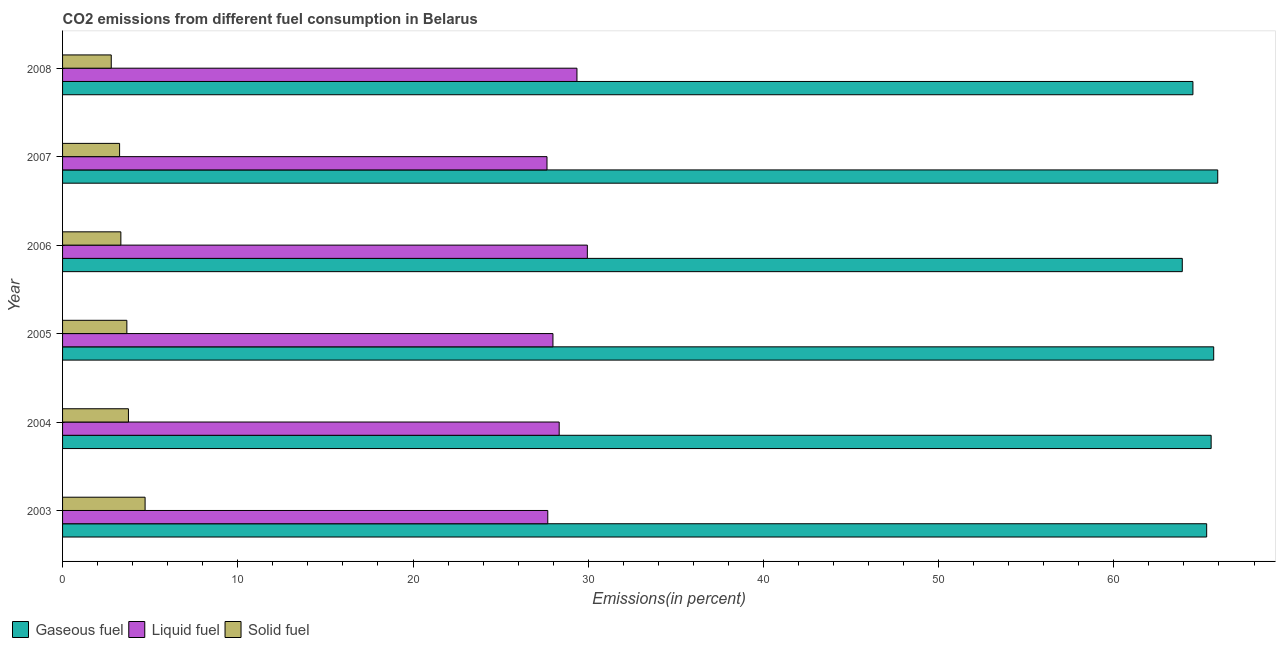How many different coloured bars are there?
Your answer should be very brief. 3. How many groups of bars are there?
Keep it short and to the point. 6. Are the number of bars per tick equal to the number of legend labels?
Offer a very short reply. Yes. What is the percentage of liquid fuel emission in 2006?
Offer a terse response. 29.95. Across all years, what is the maximum percentage of gaseous fuel emission?
Give a very brief answer. 65.93. Across all years, what is the minimum percentage of liquid fuel emission?
Your answer should be compact. 27.65. What is the total percentage of solid fuel emission in the graph?
Make the answer very short. 21.5. What is the difference between the percentage of gaseous fuel emission in 2008 and the percentage of solid fuel emission in 2003?
Make the answer very short. 59.8. What is the average percentage of gaseous fuel emission per year?
Offer a very short reply. 65.15. In the year 2003, what is the difference between the percentage of gaseous fuel emission and percentage of solid fuel emission?
Offer a terse response. 60.59. In how many years, is the percentage of solid fuel emission greater than 58 %?
Provide a short and direct response. 0. What is the ratio of the percentage of solid fuel emission in 2005 to that in 2007?
Provide a short and direct response. 1.13. Is the percentage of liquid fuel emission in 2003 less than that in 2004?
Keep it short and to the point. Yes. Is the difference between the percentage of liquid fuel emission in 2006 and 2008 greater than the difference between the percentage of solid fuel emission in 2006 and 2008?
Provide a short and direct response. Yes. What is the difference between the highest and the second highest percentage of gaseous fuel emission?
Ensure brevity in your answer.  0.23. What is the difference between the highest and the lowest percentage of gaseous fuel emission?
Your answer should be compact. 2.02. What does the 3rd bar from the top in 2008 represents?
Provide a short and direct response. Gaseous fuel. What does the 1st bar from the bottom in 2004 represents?
Offer a terse response. Gaseous fuel. How many bars are there?
Make the answer very short. 18. Are all the bars in the graph horizontal?
Provide a succinct answer. Yes. What is the difference between two consecutive major ticks on the X-axis?
Make the answer very short. 10. How are the legend labels stacked?
Your answer should be very brief. Horizontal. What is the title of the graph?
Your response must be concise. CO2 emissions from different fuel consumption in Belarus. What is the label or title of the X-axis?
Offer a very short reply. Emissions(in percent). What is the label or title of the Y-axis?
Make the answer very short. Year. What is the Emissions(in percent) of Gaseous fuel in 2003?
Offer a very short reply. 65.3. What is the Emissions(in percent) in Liquid fuel in 2003?
Offer a very short reply. 27.69. What is the Emissions(in percent) of Solid fuel in 2003?
Your answer should be compact. 4.71. What is the Emissions(in percent) of Gaseous fuel in 2004?
Provide a short and direct response. 65.55. What is the Emissions(in percent) in Liquid fuel in 2004?
Keep it short and to the point. 28.34. What is the Emissions(in percent) in Solid fuel in 2004?
Keep it short and to the point. 3.76. What is the Emissions(in percent) of Gaseous fuel in 2005?
Offer a very short reply. 65.7. What is the Emissions(in percent) in Liquid fuel in 2005?
Ensure brevity in your answer.  27.99. What is the Emissions(in percent) of Solid fuel in 2005?
Ensure brevity in your answer.  3.67. What is the Emissions(in percent) in Gaseous fuel in 2006?
Ensure brevity in your answer.  63.9. What is the Emissions(in percent) of Liquid fuel in 2006?
Your answer should be compact. 29.95. What is the Emissions(in percent) in Solid fuel in 2006?
Provide a short and direct response. 3.33. What is the Emissions(in percent) in Gaseous fuel in 2007?
Ensure brevity in your answer.  65.93. What is the Emissions(in percent) in Liquid fuel in 2007?
Your response must be concise. 27.65. What is the Emissions(in percent) in Solid fuel in 2007?
Provide a short and direct response. 3.25. What is the Emissions(in percent) of Gaseous fuel in 2008?
Provide a short and direct response. 64.51. What is the Emissions(in percent) in Liquid fuel in 2008?
Make the answer very short. 29.36. What is the Emissions(in percent) in Solid fuel in 2008?
Keep it short and to the point. 2.78. Across all years, what is the maximum Emissions(in percent) in Gaseous fuel?
Make the answer very short. 65.93. Across all years, what is the maximum Emissions(in percent) of Liquid fuel?
Offer a terse response. 29.95. Across all years, what is the maximum Emissions(in percent) in Solid fuel?
Give a very brief answer. 4.71. Across all years, what is the minimum Emissions(in percent) of Gaseous fuel?
Your answer should be compact. 63.9. Across all years, what is the minimum Emissions(in percent) in Liquid fuel?
Provide a succinct answer. 27.65. Across all years, what is the minimum Emissions(in percent) in Solid fuel?
Offer a very short reply. 2.78. What is the total Emissions(in percent) in Gaseous fuel in the graph?
Offer a very short reply. 390.89. What is the total Emissions(in percent) of Liquid fuel in the graph?
Offer a very short reply. 170.98. What is the total Emissions(in percent) in Solid fuel in the graph?
Offer a very short reply. 21.5. What is the difference between the Emissions(in percent) of Gaseous fuel in 2003 and that in 2004?
Your answer should be compact. -0.26. What is the difference between the Emissions(in percent) of Liquid fuel in 2003 and that in 2004?
Provide a succinct answer. -0.65. What is the difference between the Emissions(in percent) in Solid fuel in 2003 and that in 2004?
Your answer should be compact. 0.95. What is the difference between the Emissions(in percent) in Gaseous fuel in 2003 and that in 2005?
Give a very brief answer. -0.4. What is the difference between the Emissions(in percent) in Liquid fuel in 2003 and that in 2005?
Provide a succinct answer. -0.29. What is the difference between the Emissions(in percent) in Solid fuel in 2003 and that in 2005?
Make the answer very short. 1.04. What is the difference between the Emissions(in percent) in Gaseous fuel in 2003 and that in 2006?
Your answer should be very brief. 1.39. What is the difference between the Emissions(in percent) of Liquid fuel in 2003 and that in 2006?
Keep it short and to the point. -2.26. What is the difference between the Emissions(in percent) in Solid fuel in 2003 and that in 2006?
Your response must be concise. 1.38. What is the difference between the Emissions(in percent) in Gaseous fuel in 2003 and that in 2007?
Keep it short and to the point. -0.63. What is the difference between the Emissions(in percent) of Liquid fuel in 2003 and that in 2007?
Provide a succinct answer. 0.05. What is the difference between the Emissions(in percent) of Solid fuel in 2003 and that in 2007?
Provide a short and direct response. 1.46. What is the difference between the Emissions(in percent) of Gaseous fuel in 2003 and that in 2008?
Your response must be concise. 0.78. What is the difference between the Emissions(in percent) in Liquid fuel in 2003 and that in 2008?
Offer a terse response. -1.67. What is the difference between the Emissions(in percent) of Solid fuel in 2003 and that in 2008?
Your response must be concise. 1.93. What is the difference between the Emissions(in percent) in Gaseous fuel in 2004 and that in 2005?
Your response must be concise. -0.15. What is the difference between the Emissions(in percent) in Liquid fuel in 2004 and that in 2005?
Provide a short and direct response. 0.36. What is the difference between the Emissions(in percent) in Solid fuel in 2004 and that in 2005?
Offer a terse response. 0.09. What is the difference between the Emissions(in percent) in Gaseous fuel in 2004 and that in 2006?
Provide a short and direct response. 1.65. What is the difference between the Emissions(in percent) of Liquid fuel in 2004 and that in 2006?
Provide a short and direct response. -1.61. What is the difference between the Emissions(in percent) of Solid fuel in 2004 and that in 2006?
Your response must be concise. 0.43. What is the difference between the Emissions(in percent) of Gaseous fuel in 2004 and that in 2007?
Your response must be concise. -0.38. What is the difference between the Emissions(in percent) of Liquid fuel in 2004 and that in 2007?
Ensure brevity in your answer.  0.7. What is the difference between the Emissions(in percent) in Solid fuel in 2004 and that in 2007?
Keep it short and to the point. 0.5. What is the difference between the Emissions(in percent) of Liquid fuel in 2004 and that in 2008?
Ensure brevity in your answer.  -1.01. What is the difference between the Emissions(in percent) of Solid fuel in 2004 and that in 2008?
Your answer should be very brief. 0.98. What is the difference between the Emissions(in percent) of Gaseous fuel in 2005 and that in 2006?
Ensure brevity in your answer.  1.79. What is the difference between the Emissions(in percent) of Liquid fuel in 2005 and that in 2006?
Your answer should be compact. -1.96. What is the difference between the Emissions(in percent) of Solid fuel in 2005 and that in 2006?
Give a very brief answer. 0.34. What is the difference between the Emissions(in percent) in Gaseous fuel in 2005 and that in 2007?
Provide a short and direct response. -0.23. What is the difference between the Emissions(in percent) in Liquid fuel in 2005 and that in 2007?
Ensure brevity in your answer.  0.34. What is the difference between the Emissions(in percent) of Solid fuel in 2005 and that in 2007?
Your response must be concise. 0.41. What is the difference between the Emissions(in percent) of Gaseous fuel in 2005 and that in 2008?
Your answer should be compact. 1.19. What is the difference between the Emissions(in percent) in Liquid fuel in 2005 and that in 2008?
Provide a succinct answer. -1.37. What is the difference between the Emissions(in percent) in Solid fuel in 2005 and that in 2008?
Keep it short and to the point. 0.89. What is the difference between the Emissions(in percent) in Gaseous fuel in 2006 and that in 2007?
Give a very brief answer. -2.02. What is the difference between the Emissions(in percent) in Liquid fuel in 2006 and that in 2007?
Keep it short and to the point. 2.3. What is the difference between the Emissions(in percent) in Solid fuel in 2006 and that in 2007?
Offer a terse response. 0.07. What is the difference between the Emissions(in percent) in Gaseous fuel in 2006 and that in 2008?
Your answer should be compact. -0.61. What is the difference between the Emissions(in percent) in Liquid fuel in 2006 and that in 2008?
Offer a very short reply. 0.59. What is the difference between the Emissions(in percent) of Solid fuel in 2006 and that in 2008?
Give a very brief answer. 0.55. What is the difference between the Emissions(in percent) of Gaseous fuel in 2007 and that in 2008?
Ensure brevity in your answer.  1.42. What is the difference between the Emissions(in percent) in Liquid fuel in 2007 and that in 2008?
Provide a short and direct response. -1.71. What is the difference between the Emissions(in percent) of Solid fuel in 2007 and that in 2008?
Keep it short and to the point. 0.48. What is the difference between the Emissions(in percent) in Gaseous fuel in 2003 and the Emissions(in percent) in Liquid fuel in 2004?
Provide a succinct answer. 36.95. What is the difference between the Emissions(in percent) of Gaseous fuel in 2003 and the Emissions(in percent) of Solid fuel in 2004?
Your answer should be compact. 61.54. What is the difference between the Emissions(in percent) in Liquid fuel in 2003 and the Emissions(in percent) in Solid fuel in 2004?
Your answer should be very brief. 23.93. What is the difference between the Emissions(in percent) in Gaseous fuel in 2003 and the Emissions(in percent) in Liquid fuel in 2005?
Offer a very short reply. 37.31. What is the difference between the Emissions(in percent) in Gaseous fuel in 2003 and the Emissions(in percent) in Solid fuel in 2005?
Keep it short and to the point. 61.63. What is the difference between the Emissions(in percent) of Liquid fuel in 2003 and the Emissions(in percent) of Solid fuel in 2005?
Offer a terse response. 24.02. What is the difference between the Emissions(in percent) in Gaseous fuel in 2003 and the Emissions(in percent) in Liquid fuel in 2006?
Make the answer very short. 35.35. What is the difference between the Emissions(in percent) of Gaseous fuel in 2003 and the Emissions(in percent) of Solid fuel in 2006?
Make the answer very short. 61.97. What is the difference between the Emissions(in percent) of Liquid fuel in 2003 and the Emissions(in percent) of Solid fuel in 2006?
Offer a terse response. 24.37. What is the difference between the Emissions(in percent) of Gaseous fuel in 2003 and the Emissions(in percent) of Liquid fuel in 2007?
Your answer should be compact. 37.65. What is the difference between the Emissions(in percent) of Gaseous fuel in 2003 and the Emissions(in percent) of Solid fuel in 2007?
Give a very brief answer. 62.04. What is the difference between the Emissions(in percent) of Liquid fuel in 2003 and the Emissions(in percent) of Solid fuel in 2007?
Give a very brief answer. 24.44. What is the difference between the Emissions(in percent) in Gaseous fuel in 2003 and the Emissions(in percent) in Liquid fuel in 2008?
Your response must be concise. 35.94. What is the difference between the Emissions(in percent) of Gaseous fuel in 2003 and the Emissions(in percent) of Solid fuel in 2008?
Make the answer very short. 62.52. What is the difference between the Emissions(in percent) in Liquid fuel in 2003 and the Emissions(in percent) in Solid fuel in 2008?
Your answer should be very brief. 24.91. What is the difference between the Emissions(in percent) of Gaseous fuel in 2004 and the Emissions(in percent) of Liquid fuel in 2005?
Your response must be concise. 37.56. What is the difference between the Emissions(in percent) in Gaseous fuel in 2004 and the Emissions(in percent) in Solid fuel in 2005?
Your answer should be very brief. 61.88. What is the difference between the Emissions(in percent) of Liquid fuel in 2004 and the Emissions(in percent) of Solid fuel in 2005?
Your answer should be very brief. 24.67. What is the difference between the Emissions(in percent) in Gaseous fuel in 2004 and the Emissions(in percent) in Liquid fuel in 2006?
Offer a terse response. 35.6. What is the difference between the Emissions(in percent) of Gaseous fuel in 2004 and the Emissions(in percent) of Solid fuel in 2006?
Provide a succinct answer. 62.23. What is the difference between the Emissions(in percent) of Liquid fuel in 2004 and the Emissions(in percent) of Solid fuel in 2006?
Give a very brief answer. 25.02. What is the difference between the Emissions(in percent) of Gaseous fuel in 2004 and the Emissions(in percent) of Liquid fuel in 2007?
Your answer should be very brief. 37.9. What is the difference between the Emissions(in percent) of Gaseous fuel in 2004 and the Emissions(in percent) of Solid fuel in 2007?
Provide a succinct answer. 62.3. What is the difference between the Emissions(in percent) in Liquid fuel in 2004 and the Emissions(in percent) in Solid fuel in 2007?
Give a very brief answer. 25.09. What is the difference between the Emissions(in percent) of Gaseous fuel in 2004 and the Emissions(in percent) of Liquid fuel in 2008?
Provide a succinct answer. 36.19. What is the difference between the Emissions(in percent) of Gaseous fuel in 2004 and the Emissions(in percent) of Solid fuel in 2008?
Your response must be concise. 62.77. What is the difference between the Emissions(in percent) of Liquid fuel in 2004 and the Emissions(in percent) of Solid fuel in 2008?
Keep it short and to the point. 25.57. What is the difference between the Emissions(in percent) in Gaseous fuel in 2005 and the Emissions(in percent) in Liquid fuel in 2006?
Make the answer very short. 35.75. What is the difference between the Emissions(in percent) of Gaseous fuel in 2005 and the Emissions(in percent) of Solid fuel in 2006?
Offer a very short reply. 62.37. What is the difference between the Emissions(in percent) of Liquid fuel in 2005 and the Emissions(in percent) of Solid fuel in 2006?
Your answer should be compact. 24.66. What is the difference between the Emissions(in percent) in Gaseous fuel in 2005 and the Emissions(in percent) in Liquid fuel in 2007?
Provide a short and direct response. 38.05. What is the difference between the Emissions(in percent) of Gaseous fuel in 2005 and the Emissions(in percent) of Solid fuel in 2007?
Your answer should be compact. 62.44. What is the difference between the Emissions(in percent) in Liquid fuel in 2005 and the Emissions(in percent) in Solid fuel in 2007?
Provide a short and direct response. 24.73. What is the difference between the Emissions(in percent) in Gaseous fuel in 2005 and the Emissions(in percent) in Liquid fuel in 2008?
Provide a short and direct response. 36.34. What is the difference between the Emissions(in percent) of Gaseous fuel in 2005 and the Emissions(in percent) of Solid fuel in 2008?
Ensure brevity in your answer.  62.92. What is the difference between the Emissions(in percent) of Liquid fuel in 2005 and the Emissions(in percent) of Solid fuel in 2008?
Make the answer very short. 25.21. What is the difference between the Emissions(in percent) in Gaseous fuel in 2006 and the Emissions(in percent) in Liquid fuel in 2007?
Offer a terse response. 36.26. What is the difference between the Emissions(in percent) in Gaseous fuel in 2006 and the Emissions(in percent) in Solid fuel in 2007?
Your answer should be very brief. 60.65. What is the difference between the Emissions(in percent) in Liquid fuel in 2006 and the Emissions(in percent) in Solid fuel in 2007?
Make the answer very short. 26.7. What is the difference between the Emissions(in percent) in Gaseous fuel in 2006 and the Emissions(in percent) in Liquid fuel in 2008?
Provide a short and direct response. 34.55. What is the difference between the Emissions(in percent) in Gaseous fuel in 2006 and the Emissions(in percent) in Solid fuel in 2008?
Provide a short and direct response. 61.13. What is the difference between the Emissions(in percent) in Liquid fuel in 2006 and the Emissions(in percent) in Solid fuel in 2008?
Give a very brief answer. 27.17. What is the difference between the Emissions(in percent) in Gaseous fuel in 2007 and the Emissions(in percent) in Liquid fuel in 2008?
Your answer should be compact. 36.57. What is the difference between the Emissions(in percent) of Gaseous fuel in 2007 and the Emissions(in percent) of Solid fuel in 2008?
Offer a very short reply. 63.15. What is the difference between the Emissions(in percent) of Liquid fuel in 2007 and the Emissions(in percent) of Solid fuel in 2008?
Keep it short and to the point. 24.87. What is the average Emissions(in percent) in Gaseous fuel per year?
Provide a succinct answer. 65.15. What is the average Emissions(in percent) of Liquid fuel per year?
Your response must be concise. 28.5. What is the average Emissions(in percent) of Solid fuel per year?
Provide a succinct answer. 3.58. In the year 2003, what is the difference between the Emissions(in percent) of Gaseous fuel and Emissions(in percent) of Liquid fuel?
Provide a succinct answer. 37.6. In the year 2003, what is the difference between the Emissions(in percent) of Gaseous fuel and Emissions(in percent) of Solid fuel?
Your answer should be compact. 60.59. In the year 2003, what is the difference between the Emissions(in percent) in Liquid fuel and Emissions(in percent) in Solid fuel?
Ensure brevity in your answer.  22.98. In the year 2004, what is the difference between the Emissions(in percent) in Gaseous fuel and Emissions(in percent) in Liquid fuel?
Make the answer very short. 37.21. In the year 2004, what is the difference between the Emissions(in percent) in Gaseous fuel and Emissions(in percent) in Solid fuel?
Offer a very short reply. 61.79. In the year 2004, what is the difference between the Emissions(in percent) in Liquid fuel and Emissions(in percent) in Solid fuel?
Ensure brevity in your answer.  24.58. In the year 2005, what is the difference between the Emissions(in percent) in Gaseous fuel and Emissions(in percent) in Liquid fuel?
Your answer should be compact. 37.71. In the year 2005, what is the difference between the Emissions(in percent) in Gaseous fuel and Emissions(in percent) in Solid fuel?
Your answer should be compact. 62.03. In the year 2005, what is the difference between the Emissions(in percent) in Liquid fuel and Emissions(in percent) in Solid fuel?
Offer a terse response. 24.32. In the year 2006, what is the difference between the Emissions(in percent) in Gaseous fuel and Emissions(in percent) in Liquid fuel?
Provide a succinct answer. 33.95. In the year 2006, what is the difference between the Emissions(in percent) of Gaseous fuel and Emissions(in percent) of Solid fuel?
Your answer should be compact. 60.58. In the year 2006, what is the difference between the Emissions(in percent) of Liquid fuel and Emissions(in percent) of Solid fuel?
Offer a very short reply. 26.62. In the year 2007, what is the difference between the Emissions(in percent) in Gaseous fuel and Emissions(in percent) in Liquid fuel?
Provide a succinct answer. 38.28. In the year 2007, what is the difference between the Emissions(in percent) of Gaseous fuel and Emissions(in percent) of Solid fuel?
Your answer should be compact. 62.67. In the year 2007, what is the difference between the Emissions(in percent) of Liquid fuel and Emissions(in percent) of Solid fuel?
Provide a short and direct response. 24.39. In the year 2008, what is the difference between the Emissions(in percent) of Gaseous fuel and Emissions(in percent) of Liquid fuel?
Offer a terse response. 35.15. In the year 2008, what is the difference between the Emissions(in percent) in Gaseous fuel and Emissions(in percent) in Solid fuel?
Ensure brevity in your answer.  61.73. In the year 2008, what is the difference between the Emissions(in percent) in Liquid fuel and Emissions(in percent) in Solid fuel?
Your answer should be very brief. 26.58. What is the ratio of the Emissions(in percent) of Solid fuel in 2003 to that in 2004?
Give a very brief answer. 1.25. What is the ratio of the Emissions(in percent) in Gaseous fuel in 2003 to that in 2005?
Give a very brief answer. 0.99. What is the ratio of the Emissions(in percent) of Solid fuel in 2003 to that in 2005?
Your answer should be compact. 1.28. What is the ratio of the Emissions(in percent) of Gaseous fuel in 2003 to that in 2006?
Provide a succinct answer. 1.02. What is the ratio of the Emissions(in percent) of Liquid fuel in 2003 to that in 2006?
Make the answer very short. 0.92. What is the ratio of the Emissions(in percent) in Solid fuel in 2003 to that in 2006?
Your response must be concise. 1.42. What is the ratio of the Emissions(in percent) in Solid fuel in 2003 to that in 2007?
Offer a very short reply. 1.45. What is the ratio of the Emissions(in percent) of Gaseous fuel in 2003 to that in 2008?
Offer a terse response. 1.01. What is the ratio of the Emissions(in percent) of Liquid fuel in 2003 to that in 2008?
Provide a succinct answer. 0.94. What is the ratio of the Emissions(in percent) in Solid fuel in 2003 to that in 2008?
Provide a short and direct response. 1.7. What is the ratio of the Emissions(in percent) in Liquid fuel in 2004 to that in 2005?
Make the answer very short. 1.01. What is the ratio of the Emissions(in percent) in Solid fuel in 2004 to that in 2005?
Provide a short and direct response. 1.02. What is the ratio of the Emissions(in percent) of Gaseous fuel in 2004 to that in 2006?
Make the answer very short. 1.03. What is the ratio of the Emissions(in percent) of Liquid fuel in 2004 to that in 2006?
Make the answer very short. 0.95. What is the ratio of the Emissions(in percent) of Solid fuel in 2004 to that in 2006?
Keep it short and to the point. 1.13. What is the ratio of the Emissions(in percent) in Gaseous fuel in 2004 to that in 2007?
Give a very brief answer. 0.99. What is the ratio of the Emissions(in percent) in Liquid fuel in 2004 to that in 2007?
Offer a terse response. 1.03. What is the ratio of the Emissions(in percent) in Solid fuel in 2004 to that in 2007?
Give a very brief answer. 1.16. What is the ratio of the Emissions(in percent) of Gaseous fuel in 2004 to that in 2008?
Make the answer very short. 1.02. What is the ratio of the Emissions(in percent) of Liquid fuel in 2004 to that in 2008?
Your answer should be very brief. 0.97. What is the ratio of the Emissions(in percent) in Solid fuel in 2004 to that in 2008?
Make the answer very short. 1.35. What is the ratio of the Emissions(in percent) of Gaseous fuel in 2005 to that in 2006?
Your response must be concise. 1.03. What is the ratio of the Emissions(in percent) of Liquid fuel in 2005 to that in 2006?
Offer a very short reply. 0.93. What is the ratio of the Emissions(in percent) of Solid fuel in 2005 to that in 2006?
Your answer should be very brief. 1.1. What is the ratio of the Emissions(in percent) in Gaseous fuel in 2005 to that in 2007?
Keep it short and to the point. 1. What is the ratio of the Emissions(in percent) of Liquid fuel in 2005 to that in 2007?
Offer a terse response. 1.01. What is the ratio of the Emissions(in percent) in Solid fuel in 2005 to that in 2007?
Provide a short and direct response. 1.13. What is the ratio of the Emissions(in percent) in Gaseous fuel in 2005 to that in 2008?
Provide a short and direct response. 1.02. What is the ratio of the Emissions(in percent) of Liquid fuel in 2005 to that in 2008?
Ensure brevity in your answer.  0.95. What is the ratio of the Emissions(in percent) in Solid fuel in 2005 to that in 2008?
Ensure brevity in your answer.  1.32. What is the ratio of the Emissions(in percent) in Gaseous fuel in 2006 to that in 2007?
Your answer should be very brief. 0.97. What is the ratio of the Emissions(in percent) in Liquid fuel in 2006 to that in 2007?
Offer a terse response. 1.08. What is the ratio of the Emissions(in percent) of Solid fuel in 2006 to that in 2007?
Offer a terse response. 1.02. What is the ratio of the Emissions(in percent) of Gaseous fuel in 2006 to that in 2008?
Give a very brief answer. 0.99. What is the ratio of the Emissions(in percent) in Liquid fuel in 2006 to that in 2008?
Offer a very short reply. 1.02. What is the ratio of the Emissions(in percent) in Solid fuel in 2006 to that in 2008?
Your answer should be very brief. 1.2. What is the ratio of the Emissions(in percent) of Gaseous fuel in 2007 to that in 2008?
Ensure brevity in your answer.  1.02. What is the ratio of the Emissions(in percent) in Liquid fuel in 2007 to that in 2008?
Give a very brief answer. 0.94. What is the ratio of the Emissions(in percent) of Solid fuel in 2007 to that in 2008?
Provide a short and direct response. 1.17. What is the difference between the highest and the second highest Emissions(in percent) in Gaseous fuel?
Offer a terse response. 0.23. What is the difference between the highest and the second highest Emissions(in percent) in Liquid fuel?
Your response must be concise. 0.59. What is the difference between the highest and the second highest Emissions(in percent) in Solid fuel?
Provide a short and direct response. 0.95. What is the difference between the highest and the lowest Emissions(in percent) of Gaseous fuel?
Give a very brief answer. 2.02. What is the difference between the highest and the lowest Emissions(in percent) of Liquid fuel?
Offer a very short reply. 2.3. What is the difference between the highest and the lowest Emissions(in percent) of Solid fuel?
Your response must be concise. 1.93. 